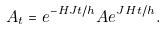Convert formula to latex. <formula><loc_0><loc_0><loc_500><loc_500>A _ { t } = e ^ { - { H } J t / h } A e ^ { J { H } t / h } .</formula> 